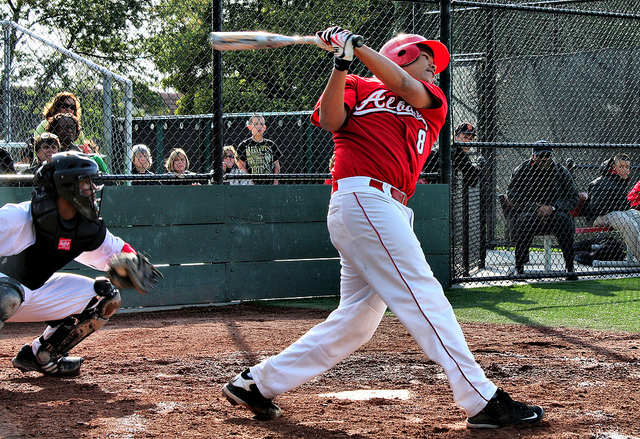Please transcribe the text in this image. 8 